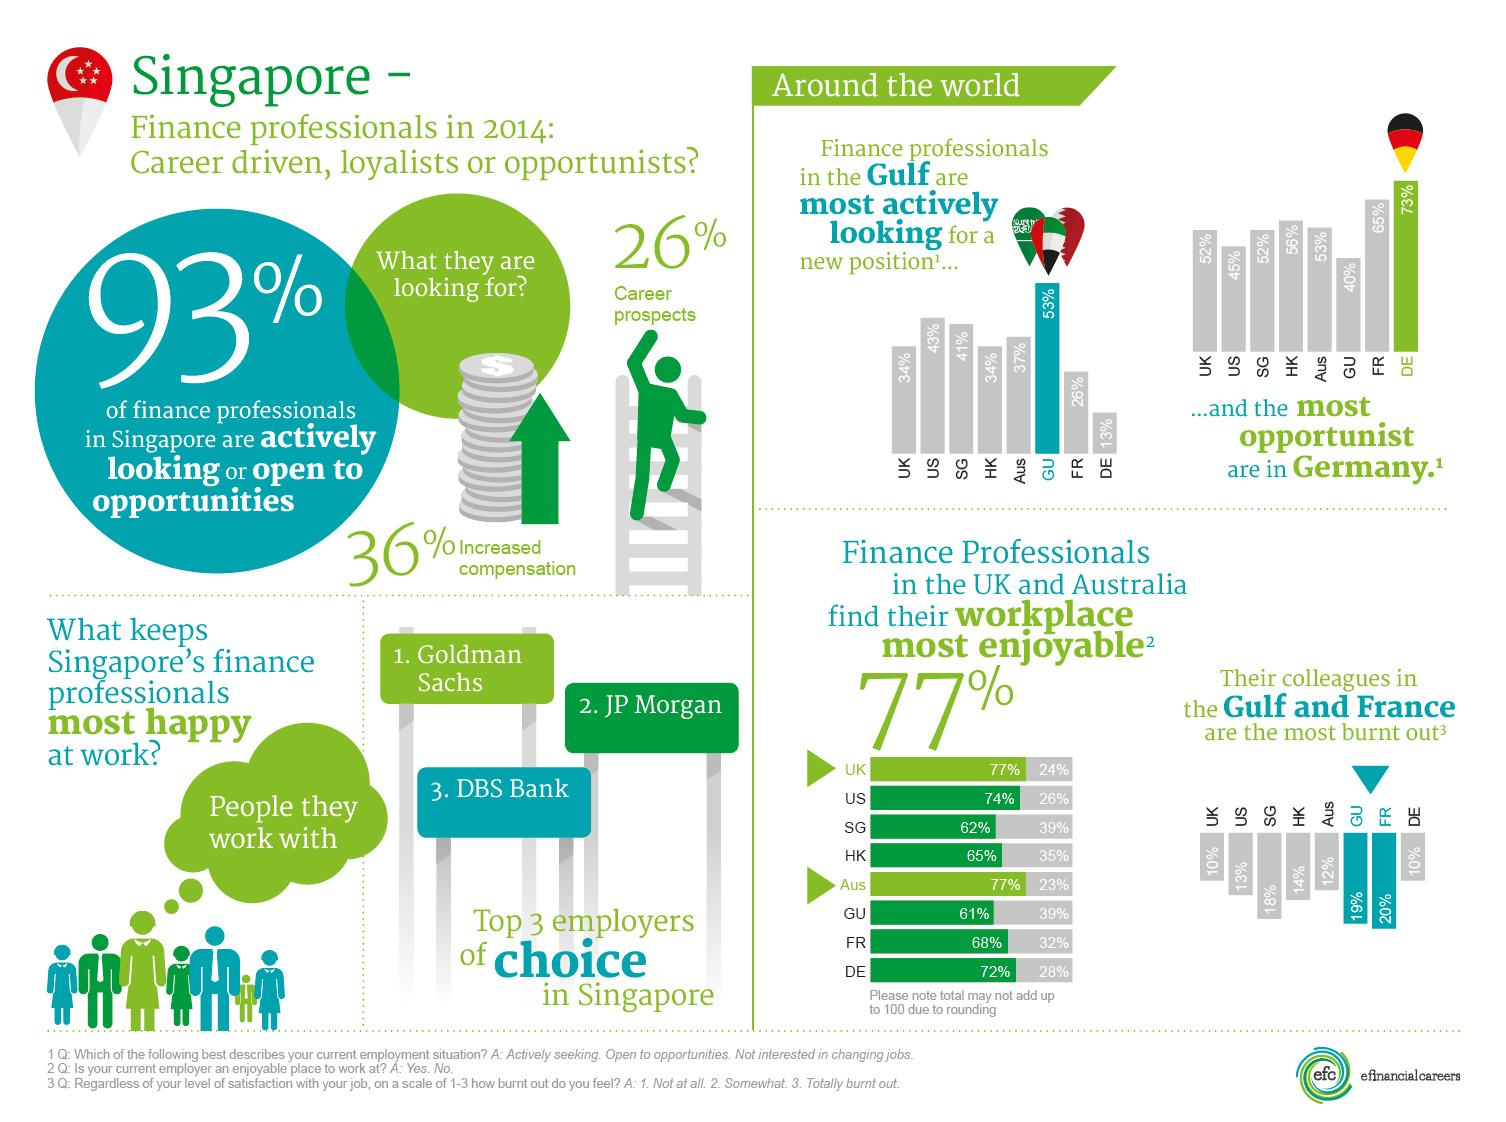Mention a couple of crucial points in this snapshot. Singaporeans tend to prefer employers such as Goldman Sachs, JP Morgan, and DBS Bank. 